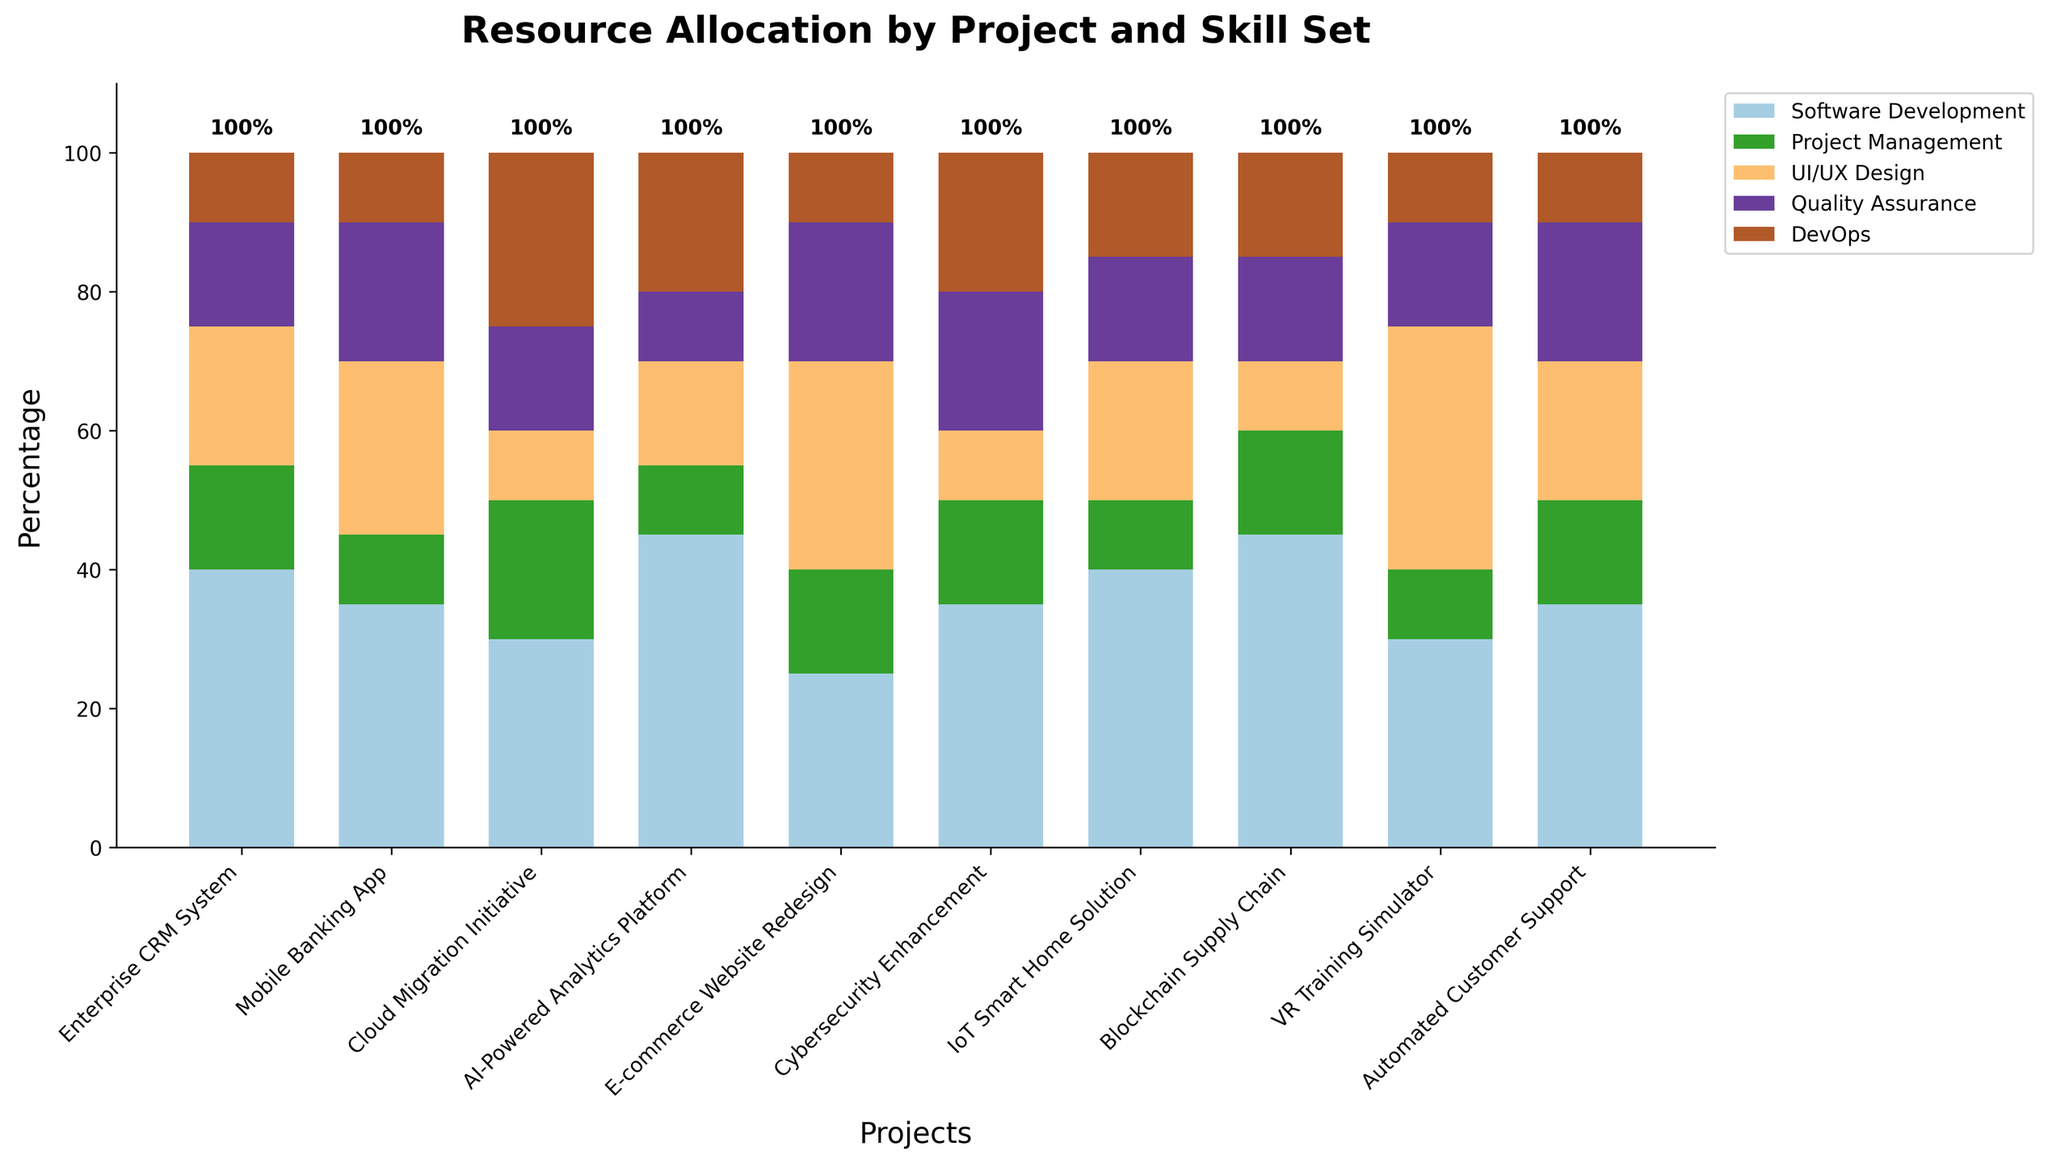Which project requires the highest percentage of Software Development? By reviewing the height of the section in each bar that represents Software Development, the AI-Powered Analytics Platform and Blockchain Supply Chain both have the highest at 45%.
Answer: AI-Powered Analytics Platform and Blockchain Supply Chain Which project has the least percentage allocated to DevOps? By comparing the segments allocated to DevOps across all projects, the Enterprise CRM System, Mobile Banking App, E-commerce Website Redesign, and Automated Customer Support all have 10% for DevOps, which is the minimum.
Answer: Enterprise CRM System, Mobile Banking App, E-commerce Website Redesign, and Automated Customer Support How many projects have at least 20% designated for UI/UX Design? By looking at the segments representing UI/UX Design, count the projects where the section is 20% or larger: Mobile Banking App, E-commerce Website Redesign, VR Training Simulator, and Automated Customer Support.
Answer: 4 Compare the total percentage allocated to Project Management between Cloud Migration Initiative and Cybersecurity Enhancement. Which is higher? Cloud Migration Initiative has 20% allocated for Project Management while Cybersecurity Enhancement has 15%. Thus, Cloud Migration Initiative has a higher percentage.
Answer: Cloud Migration Initiative What is the sum of percentages for Quality Assurance across all projects? Add the percentage allocations for Quality Assurance in each project: 15 + 20 + 15 + 10 + 20 + 20 + 15 + 15 + 15 + 20 = 165.
Answer: 165 Which skill set has the least variability in percentage allocation across all projects? Assessing the height differences of each skill set across projects, percentages for DevOps appear relatively consistent across all projects, as it typically hovers around 10-20%.
Answer: DevOps Between the Mobile Banking App and the IoT Smart Home Solution, which one has a higher total resource allocation percentage for the combination of Project Management and DevOps? Calculate the combined percentage for both skills:
Mobile Banking App: 10% (Project Management) + 10% (DevOps) = 20%
IoT Smart Home Solution: 10% (Project Management) + 15% (DevOps) = 25%. Thus, IoT Smart Home Solution has a higher percentage.
Answer: IoT Smart Home Solution Which two projects have identical percentages allocated to Quality Assurance? By comparing the Quality Assurance segments, the Enterprise CRM System, Cloud Migration Initiative, E-commerce Website Redesign, IoT Smart Home Solution, Blockchain Supply Chain, and VR Training Simulator each have 15% allocated.
Answer: Enterprise CRM System and IoT Smart Home Solution 